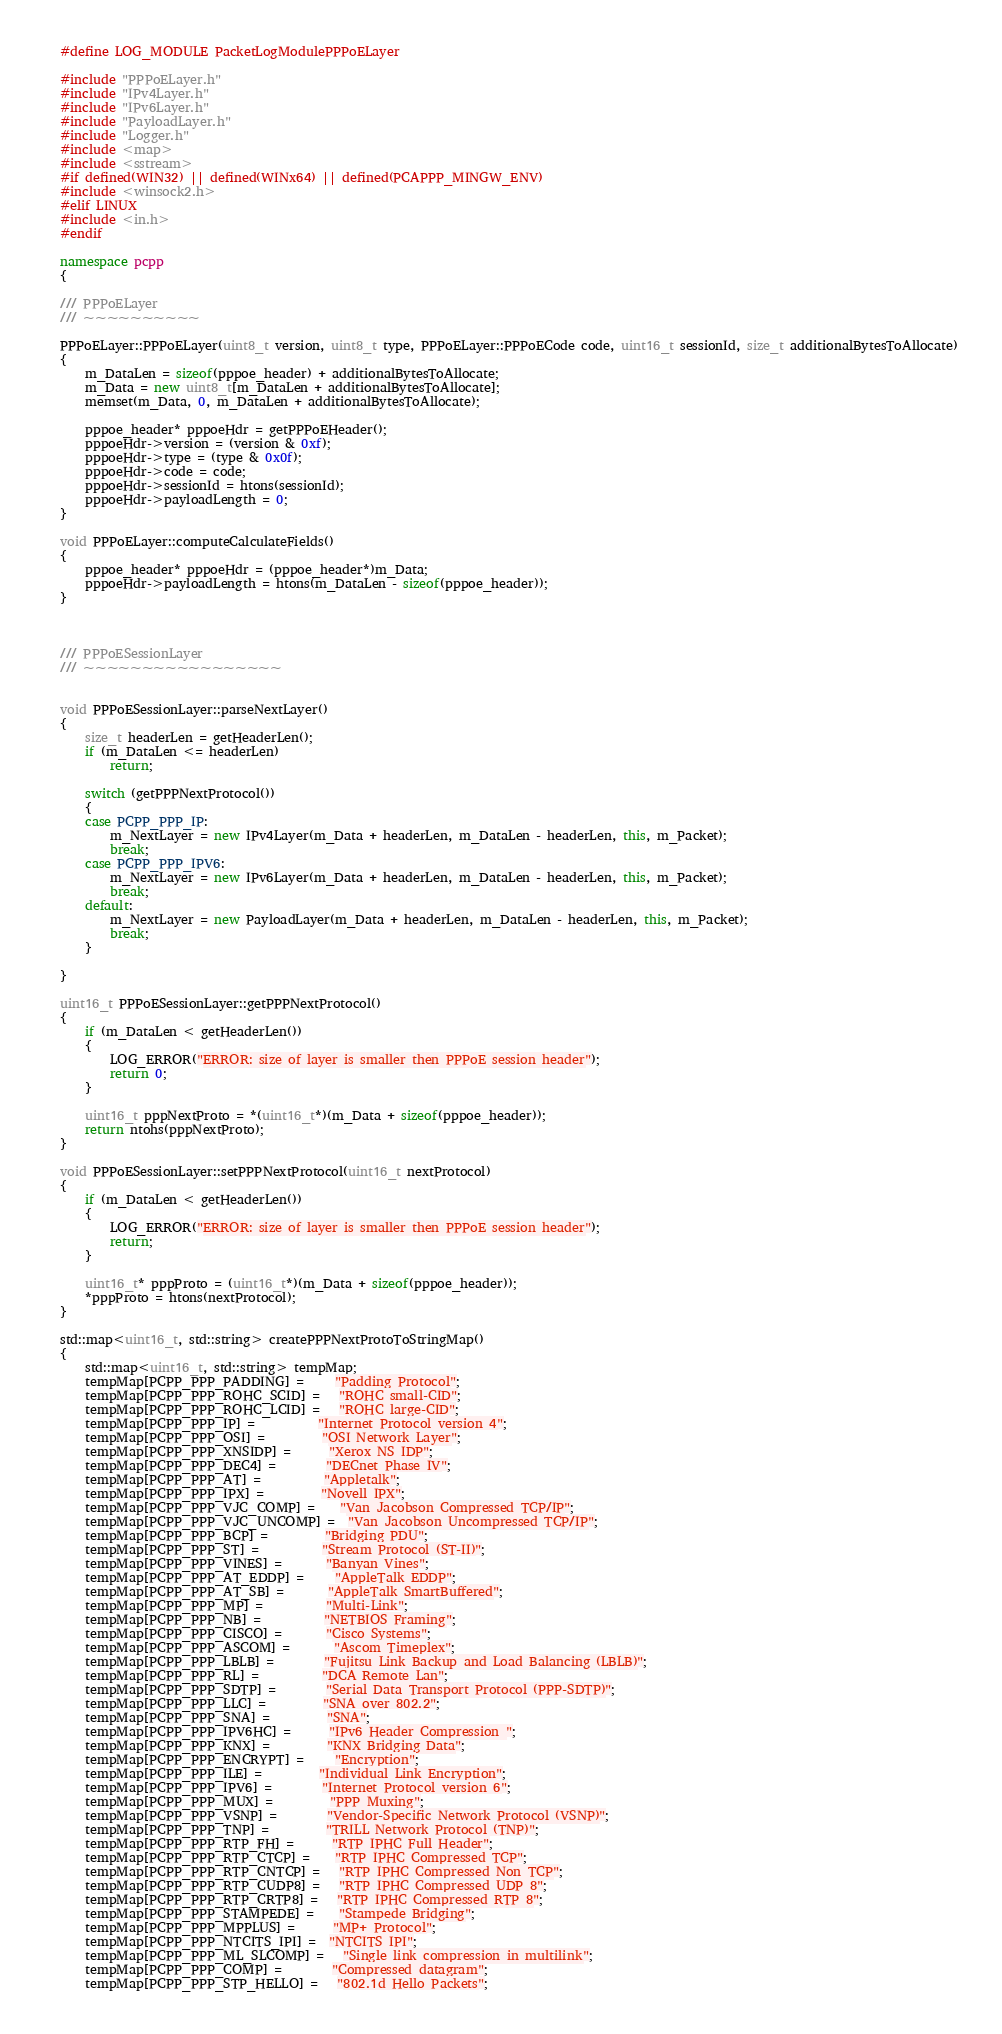Convert code to text. <code><loc_0><loc_0><loc_500><loc_500><_C++_>#define LOG_MODULE PacketLogModulePPPoELayer

#include "PPPoELayer.h"
#include "IPv4Layer.h"
#include "IPv6Layer.h"
#include "PayloadLayer.h"
#include "Logger.h"
#include <map>
#include <sstream>
#if defined(WIN32) || defined(WINx64) || defined(PCAPPP_MINGW_ENV)
#include <winsock2.h>
#elif LINUX
#include <in.h>
#endif

namespace pcpp
{

/// PPPoELayer
/// ~~~~~~~~~~

PPPoELayer::PPPoELayer(uint8_t version, uint8_t type, PPPoELayer::PPPoECode code, uint16_t sessionId, size_t additionalBytesToAllocate)
{
	m_DataLen = sizeof(pppoe_header) + additionalBytesToAllocate;
	m_Data = new uint8_t[m_DataLen + additionalBytesToAllocate];
	memset(m_Data, 0, m_DataLen + additionalBytesToAllocate);

	pppoe_header* pppoeHdr = getPPPoEHeader();
	pppoeHdr->version = (version & 0xf);
	pppoeHdr->type = (type & 0x0f);
	pppoeHdr->code = code;
	pppoeHdr->sessionId = htons(sessionId);
	pppoeHdr->payloadLength = 0;
}

void PPPoELayer::computeCalculateFields()
{
	pppoe_header* pppoeHdr = (pppoe_header*)m_Data;
	pppoeHdr->payloadLength = htons(m_DataLen - sizeof(pppoe_header));
}



/// PPPoESessionLayer
/// ~~~~~~~~~~~~~~~~~


void PPPoESessionLayer::parseNextLayer()
{
	size_t headerLen = getHeaderLen();
	if (m_DataLen <= headerLen)
		return;

	switch (getPPPNextProtocol())
	{
	case PCPP_PPP_IP:
		m_NextLayer = new IPv4Layer(m_Data + headerLen, m_DataLen - headerLen, this, m_Packet);
		break;
	case PCPP_PPP_IPV6:
		m_NextLayer = new IPv6Layer(m_Data + headerLen, m_DataLen - headerLen, this, m_Packet);
		break;
	default:
		m_NextLayer = new PayloadLayer(m_Data + headerLen, m_DataLen - headerLen, this, m_Packet);
		break;
	}

}

uint16_t PPPoESessionLayer::getPPPNextProtocol()
{
	if (m_DataLen < getHeaderLen())
	{
		LOG_ERROR("ERROR: size of layer is smaller then PPPoE session header");
		return 0;
	}

	uint16_t pppNextProto = *(uint16_t*)(m_Data + sizeof(pppoe_header));
	return ntohs(pppNextProto);
}

void PPPoESessionLayer::setPPPNextProtocol(uint16_t nextProtocol)
{
	if (m_DataLen < getHeaderLen())
	{
		LOG_ERROR("ERROR: size of layer is smaller then PPPoE session header");
		return;
	}

	uint16_t* pppProto = (uint16_t*)(m_Data + sizeof(pppoe_header));
	*pppProto = htons(nextProtocol);
}

std::map<uint16_t, std::string> createPPPNextProtoToStringMap()
{
	std::map<uint16_t, std::string> tempMap;
	tempMap[PCPP_PPP_PADDING] =     "Padding Protocol";
	tempMap[PCPP_PPP_ROHC_SCID] =   "ROHC small-CID";
	tempMap[PCPP_PPP_ROHC_LCID] =   "ROHC large-CID";
	tempMap[PCPP_PPP_IP] =          "Internet Protocol version 4";
	tempMap[PCPP_PPP_OSI] =         "OSI Network Layer";
	tempMap[PCPP_PPP_XNSIDP] =      "Xerox NS IDP";
	tempMap[PCPP_PPP_DEC4] =        "DECnet Phase IV";
	tempMap[PCPP_PPP_AT] =          "Appletalk";
	tempMap[PCPP_PPP_IPX] =         "Novell IPX";
	tempMap[PCPP_PPP_VJC_COMP] =    "Van Jacobson Compressed TCP/IP";
	tempMap[PCPP_PPP_VJC_UNCOMP] =  "Van Jacobson Uncompressed TCP/IP";
	tempMap[PCPP_PPP_BCP] =         "Bridging PDU";
	tempMap[PCPP_PPP_ST] =          "Stream Protocol (ST-II)";
	tempMap[PCPP_PPP_VINES] =       "Banyan Vines";
	tempMap[PCPP_PPP_AT_EDDP] =     "AppleTalk EDDP";
	tempMap[PCPP_PPP_AT_SB] =       "AppleTalk SmartBuffered";
	tempMap[PCPP_PPP_MP] =          "Multi-Link";
	tempMap[PCPP_PPP_NB] =          "NETBIOS Framing";
	tempMap[PCPP_PPP_CISCO] =       "Cisco Systems";
	tempMap[PCPP_PPP_ASCOM] =       "Ascom Timeplex";
	tempMap[PCPP_PPP_LBLB] =        "Fujitsu Link Backup and Load Balancing (LBLB)";
	tempMap[PCPP_PPP_RL] =          "DCA Remote Lan";
	tempMap[PCPP_PPP_SDTP] =        "Serial Data Transport Protocol (PPP-SDTP)";
	tempMap[PCPP_PPP_LLC] =         "SNA over 802.2";
	tempMap[PCPP_PPP_SNA] =         "SNA";
	tempMap[PCPP_PPP_IPV6HC] =      "IPv6 Header Compression ";
    tempMap[PCPP_PPP_KNX] =         "KNX Bridging Data";
    tempMap[PCPP_PPP_ENCRYPT] =     "Encryption";
    tempMap[PCPP_PPP_ILE] =         "Individual Link Encryption";
    tempMap[PCPP_PPP_IPV6] =        "Internet Protocol version 6";
    tempMap[PCPP_PPP_MUX] =         "PPP Muxing";
    tempMap[PCPP_PPP_VSNP] =        "Vendor-Specific Network Protocol (VSNP)";
    tempMap[PCPP_PPP_TNP] =         "TRILL Network Protocol (TNP)";
    tempMap[PCPP_PPP_RTP_FH] =      "RTP IPHC Full Header";
    tempMap[PCPP_PPP_RTP_CTCP] =    "RTP IPHC Compressed TCP";
    tempMap[PCPP_PPP_RTP_CNTCP] =   "RTP IPHC Compressed Non TCP";
    tempMap[PCPP_PPP_RTP_CUDP8] =   "RTP IPHC Compressed UDP 8";
    tempMap[PCPP_PPP_RTP_CRTP8] =   "RTP IPHC Compressed RTP 8";
    tempMap[PCPP_PPP_STAMPEDE] =    "Stampede Bridging";
    tempMap[PCPP_PPP_MPPLUS] =      "MP+ Protocol";
    tempMap[PCPP_PPP_NTCITS_IPI] =  "NTCITS IPI";
    tempMap[PCPP_PPP_ML_SLCOMP] =   "Single link compression in multilink";
    tempMap[PCPP_PPP_COMP] =        "Compressed datagram";
    tempMap[PCPP_PPP_STP_HELLO] =   "802.1d Hello Packets";</code> 